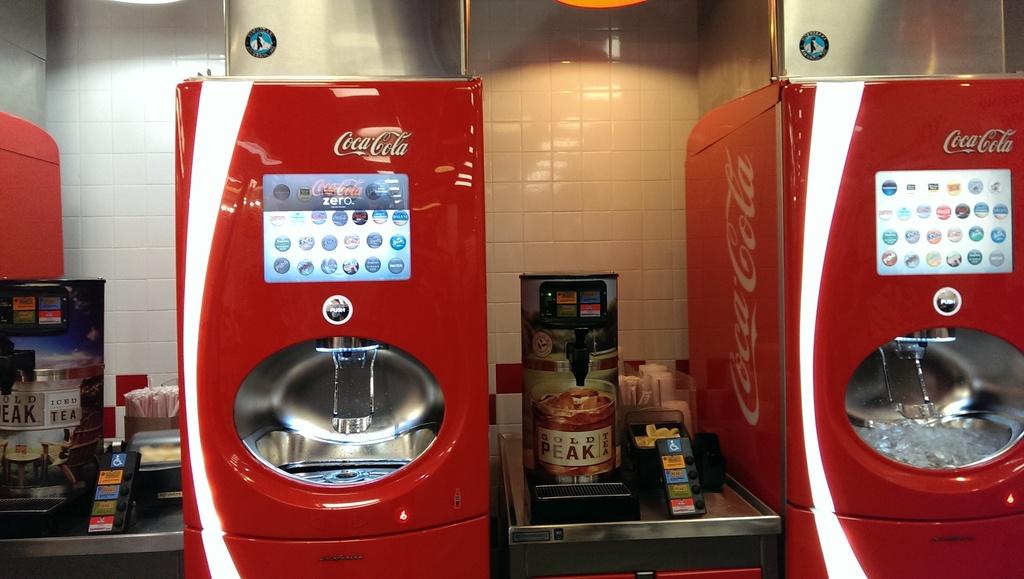Do you push or pull the button on the soda machine?
Your response must be concise. Push. What soda brand is in these machines?
Offer a very short reply. Coca-cola. 